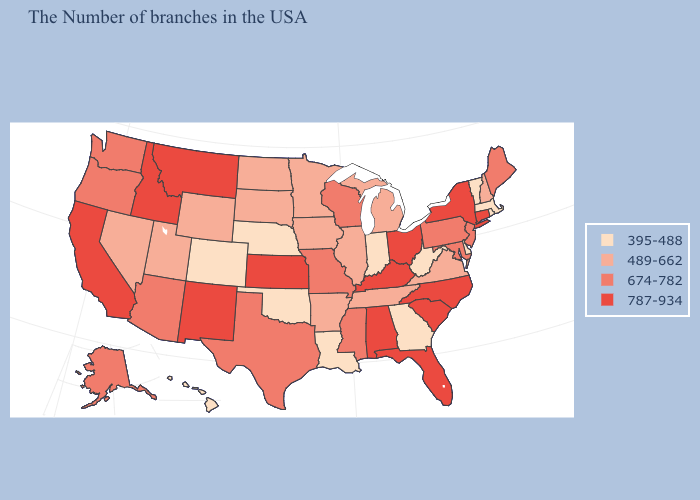What is the highest value in the West ?
Give a very brief answer. 787-934. What is the highest value in the USA?
Be succinct. 787-934. Among the states that border Connecticut , which have the highest value?
Answer briefly. New York. Does Ohio have the highest value in the MidWest?
Give a very brief answer. Yes. What is the value of North Dakota?
Answer briefly. 489-662. How many symbols are there in the legend?
Give a very brief answer. 4. What is the value of Arizona?
Quick response, please. 674-782. Does New Mexico have a higher value than North Carolina?
Concise answer only. No. Among the states that border Ohio , which have the lowest value?
Be succinct. West Virginia, Indiana. Name the states that have a value in the range 787-934?
Short answer required. Connecticut, New York, North Carolina, South Carolina, Ohio, Florida, Kentucky, Alabama, Kansas, New Mexico, Montana, Idaho, California. What is the value of Rhode Island?
Give a very brief answer. 395-488. Among the states that border Wyoming , does Utah have the highest value?
Write a very short answer. No. Name the states that have a value in the range 674-782?
Quick response, please. Maine, New Jersey, Maryland, Pennsylvania, Wisconsin, Mississippi, Missouri, Texas, Arizona, Washington, Oregon, Alaska. Which states have the lowest value in the USA?
Concise answer only. Massachusetts, Rhode Island, Vermont, Delaware, West Virginia, Georgia, Indiana, Louisiana, Nebraska, Oklahoma, Colorado, Hawaii. Name the states that have a value in the range 674-782?
Write a very short answer. Maine, New Jersey, Maryland, Pennsylvania, Wisconsin, Mississippi, Missouri, Texas, Arizona, Washington, Oregon, Alaska. 